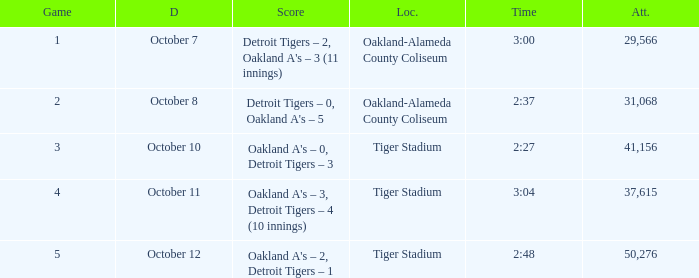What is the number of people in attendance when the time is 3:00? 29566.0. 